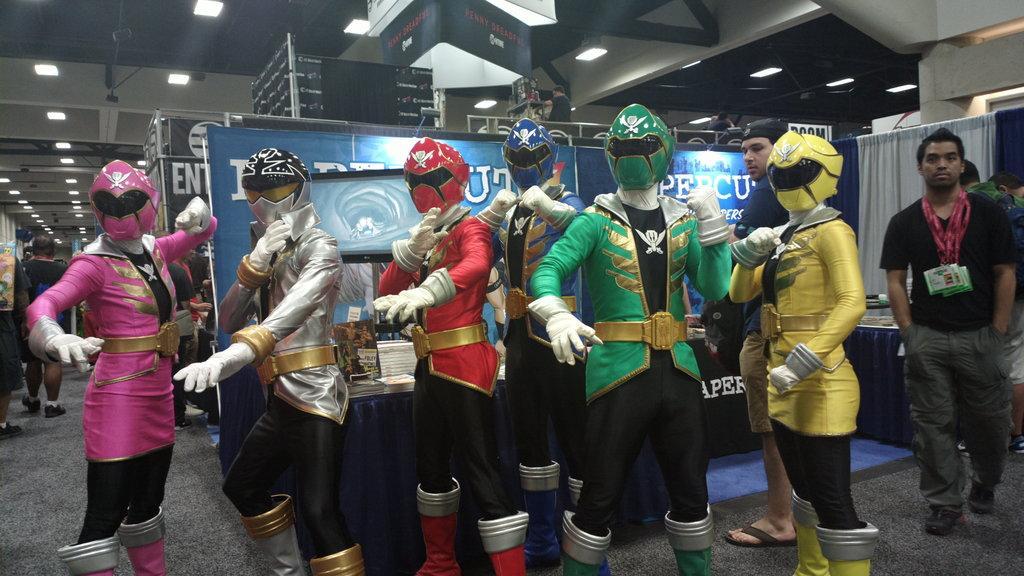In one or two sentences, can you explain what this image depicts? In this image, there are a few people. Among them, some people are wearing costumes. We can see some tables with objects. We can also see some boards with text and images. We can see the roof with some lights. 